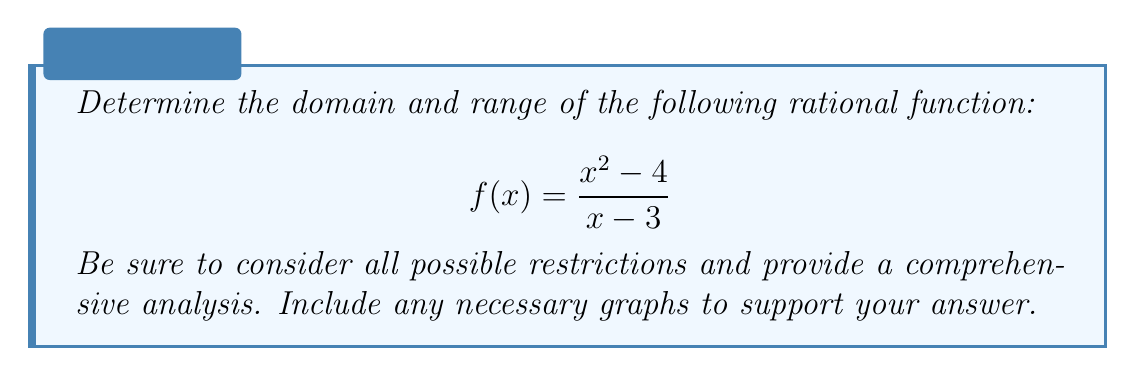Can you solve this math problem? To determine the domain and range of this rational function, we need to follow these steps:

1. Domain analysis:
   The domain of a rational function includes all real numbers except those that make the denominator zero. Let's set the denominator equal to zero and solve:
   
   $x - 3 = 0$
   $x = 3$
   
   Therefore, 3 is excluded from the domain.

2. Simplification:
   We can factor the numerator to simplify the function:
   
   $$f(x) = \frac{(x+2)(x-2)}{x-3}$$

   Note that this simplification doesn't change the domain or range.

3. Vertical asymptote:
   The vertical asymptote occurs at $x = 3$, where the denominator is zero.

4. Horizontal asymptote:
   To find the horizontal asymptote, we compare the degrees of the numerator and denominator:
   
   $\lim_{x \to \pm\infty} \frac{x^2 - 4}{x - 3} = \lim_{x \to \pm\infty} x = \pm\infty$

   There is no horizontal asymptote; instead, we have a slant asymptote.

5. Slant asymptote:
   To find the slant asymptote, we perform long division:
   
   $$\frac{x^2 - 4}{x - 3} = x + 3 + \frac{5}{x-3}$$

   The slant asymptote is $y = x + 3$.

6. Zeros of the function:
   The zeros occur when the numerator is zero:
   $x^2 - 4 = 0$
   $(x+2)(x-2) = 0$
   $x = -2$ or $x = 2$

7. Behavior near the vertical asymptote:
   As $x$ approaches 3 from the left, $f(x)$ approaches negative infinity.
   As $x$ approaches 3 from the right, $f(x)$ approaches positive infinity.

8. Graph analysis:
   [asy]
   import graph;
   size(200,200);
   
   real f(real x) {return (x^2-4)/(x-3);}
   
   xaxis("x", arrow=Arrow);
   yaxis("y", arrow=Arrow);
   
   draw(graph(f,-5,-0.1,n=500));
   draw(graph(f,0.1,2.9,n=500));
   draw(graph(f,3.1,5,n=500));
   
   draw((3,-5)--(3,5),dashed);
   draw((-5,-2)--(5,8),dashed);
   
   label("x=3", (3.2,4), E);
   label("y=x+3", (4.5,7.5), NE);
   
   dot((-2,0));
   dot((2,0));
   [/asy]

Based on this analysis, we can determine the domain and range:

Domain: All real numbers except 3, or in set notation: $\{x \in \mathbb{R} : x \neq 3\}$

Range: All real numbers, or $\mathbb{R}$. This is because the function approaches both positive and negative infinity near the vertical asymptote and follows a slant asymptote, allowing it to take on all real values.
Answer: Domain: $\{x \in \mathbb{R} : x \neq 3\}$
Range: $\mathbb{R}$ 